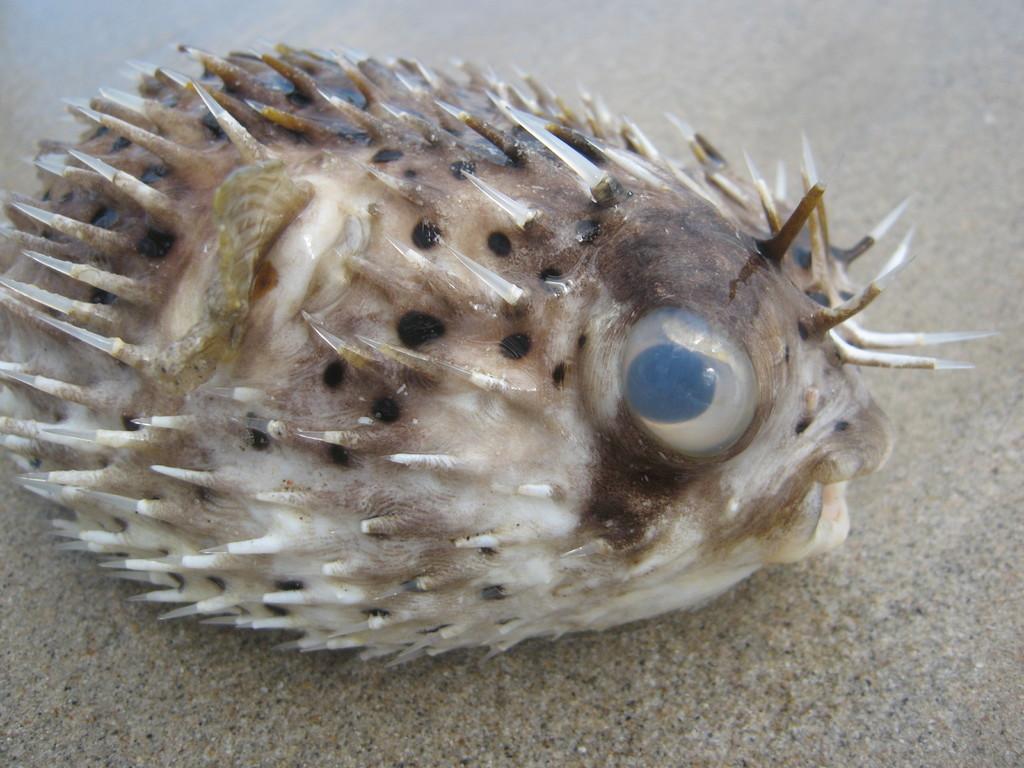How would you summarize this image in a sentence or two? In this image there is a puffer fish on the floor. 